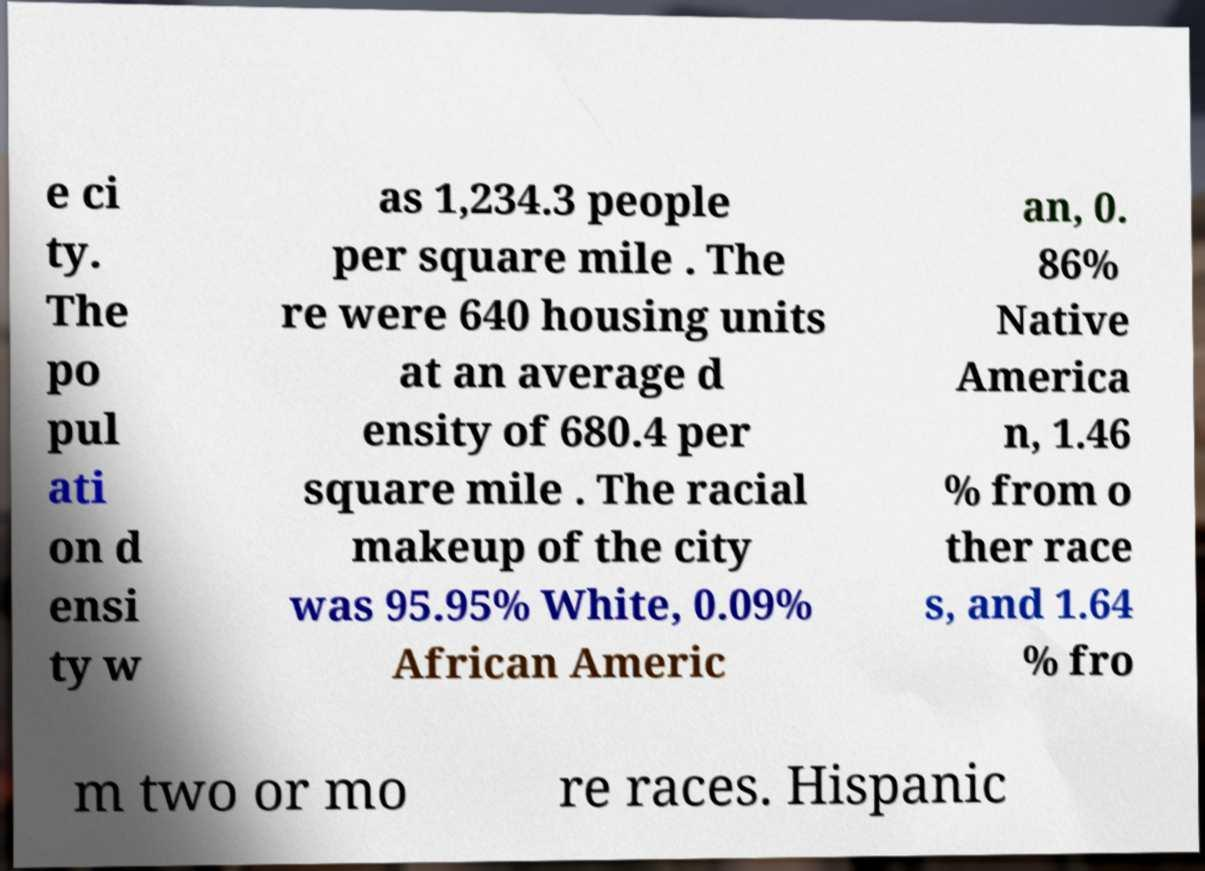Can you read and provide the text displayed in the image?This photo seems to have some interesting text. Can you extract and type it out for me? e ci ty. The po pul ati on d ensi ty w as 1,234.3 people per square mile . The re were 640 housing units at an average d ensity of 680.4 per square mile . The racial makeup of the city was 95.95% White, 0.09% African Americ an, 0. 86% Native America n, 1.46 % from o ther race s, and 1.64 % fro m two or mo re races. Hispanic 